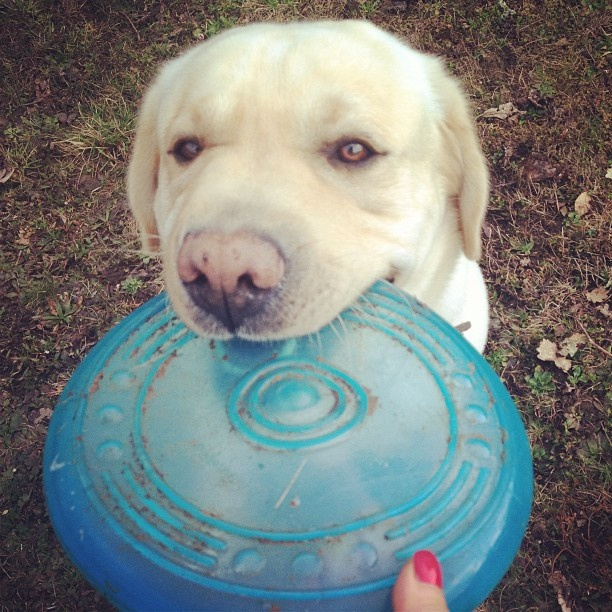Describe the objects in this image and their specific colors. I can see frisbee in black, teal, and darkgray tones, dog in black, beige, darkgray, and tan tones, and people in black, tan, brown, and salmon tones in this image. 